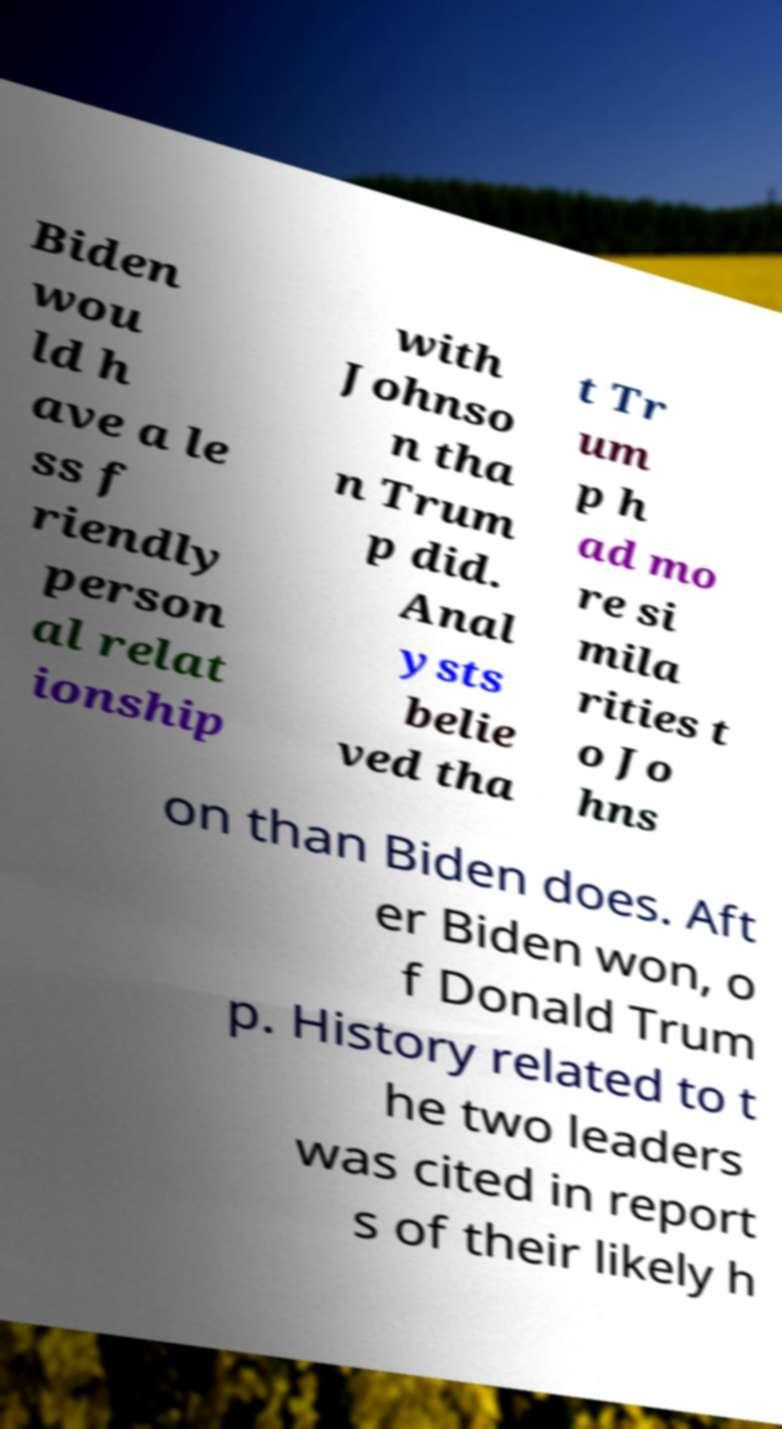I need the written content from this picture converted into text. Can you do that? Biden wou ld h ave a le ss f riendly person al relat ionship with Johnso n tha n Trum p did. Anal ysts belie ved tha t Tr um p h ad mo re si mila rities t o Jo hns on than Biden does. Aft er Biden won, o f Donald Trum p. History related to t he two leaders was cited in report s of their likely h 